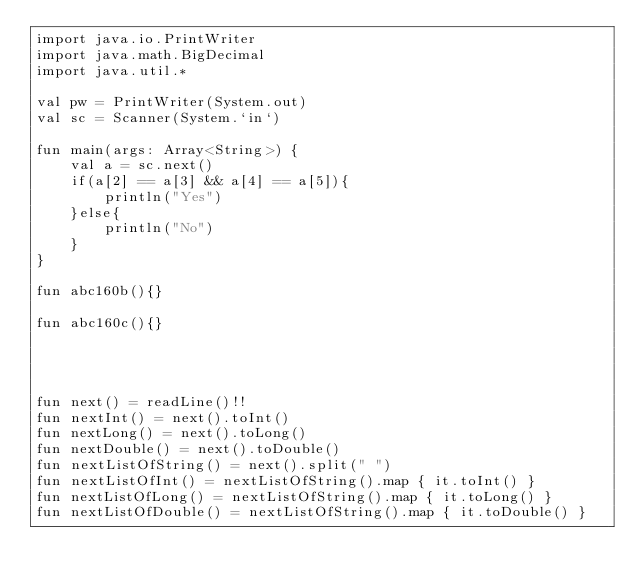<code> <loc_0><loc_0><loc_500><loc_500><_Kotlin_>import java.io.PrintWriter
import java.math.BigDecimal
import java.util.*

val pw = PrintWriter(System.out)
val sc = Scanner(System.`in`)

fun main(args: Array<String>) {
    val a = sc.next()
    if(a[2] == a[3] && a[4] == a[5]){
        println("Yes")
    }else{
        println("No")
    }
}

fun abc160b(){}

fun abc160c(){}




fun next() = readLine()!!
fun nextInt() = next().toInt()
fun nextLong() = next().toLong()
fun nextDouble() = next().toDouble()
fun nextListOfString() = next().split(" ")
fun nextListOfInt() = nextListOfString().map { it.toInt() }
fun nextListOfLong() = nextListOfString().map { it.toLong() }
fun nextListOfDouble() = nextListOfString().map { it.toDouble() }

</code> 